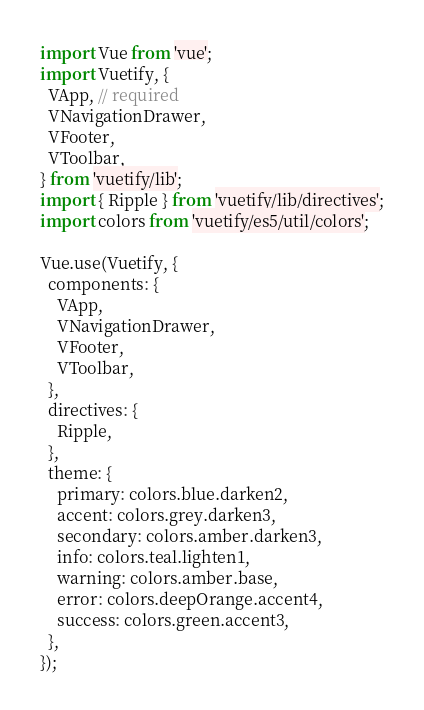<code> <loc_0><loc_0><loc_500><loc_500><_JavaScript_>import Vue from 'vue';
import Vuetify, {
  VApp, // required
  VNavigationDrawer,
  VFooter,
  VToolbar,
} from 'vuetify/lib';
import { Ripple } from 'vuetify/lib/directives';
import colors from 'vuetify/es5/util/colors';

Vue.use(Vuetify, {
  components: {
    VApp,
    VNavigationDrawer,
    VFooter,
    VToolbar,
  },
  directives: {
    Ripple,
  },
  theme: {
    primary: colors.blue.darken2,
    accent: colors.grey.darken3,
    secondary: colors.amber.darken3,
    info: colors.teal.lighten1,
    warning: colors.amber.base,
    error: colors.deepOrange.accent4,
    success: colors.green.accent3,
  },
});
</code> 